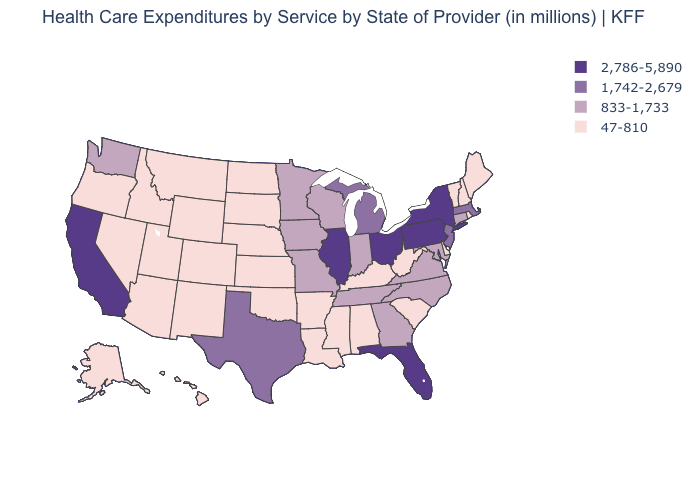Among the states that border Kansas , does Missouri have the lowest value?
Write a very short answer. No. Is the legend a continuous bar?
Keep it brief. No. Which states have the lowest value in the USA?
Short answer required. Alabama, Alaska, Arizona, Arkansas, Colorado, Delaware, Hawaii, Idaho, Kansas, Kentucky, Louisiana, Maine, Mississippi, Montana, Nebraska, Nevada, New Hampshire, New Mexico, North Dakota, Oklahoma, Oregon, Rhode Island, South Carolina, South Dakota, Utah, Vermont, West Virginia, Wyoming. What is the lowest value in the USA?
Short answer required. 47-810. Which states have the lowest value in the USA?
Short answer required. Alabama, Alaska, Arizona, Arkansas, Colorado, Delaware, Hawaii, Idaho, Kansas, Kentucky, Louisiana, Maine, Mississippi, Montana, Nebraska, Nevada, New Hampshire, New Mexico, North Dakota, Oklahoma, Oregon, Rhode Island, South Carolina, South Dakota, Utah, Vermont, West Virginia, Wyoming. How many symbols are there in the legend?
Give a very brief answer. 4. Is the legend a continuous bar?
Quick response, please. No. Name the states that have a value in the range 47-810?
Give a very brief answer. Alabama, Alaska, Arizona, Arkansas, Colorado, Delaware, Hawaii, Idaho, Kansas, Kentucky, Louisiana, Maine, Mississippi, Montana, Nebraska, Nevada, New Hampshire, New Mexico, North Dakota, Oklahoma, Oregon, Rhode Island, South Carolina, South Dakota, Utah, Vermont, West Virginia, Wyoming. What is the value of Colorado?
Quick response, please. 47-810. Among the states that border Alabama , does Mississippi have the lowest value?
Be succinct. Yes. What is the value of North Dakota?
Concise answer only. 47-810. Does the first symbol in the legend represent the smallest category?
Write a very short answer. No. Name the states that have a value in the range 1,742-2,679?
Answer briefly. Massachusetts, Michigan, New Jersey, Texas. What is the value of Connecticut?
Be succinct. 833-1,733. How many symbols are there in the legend?
Write a very short answer. 4. 